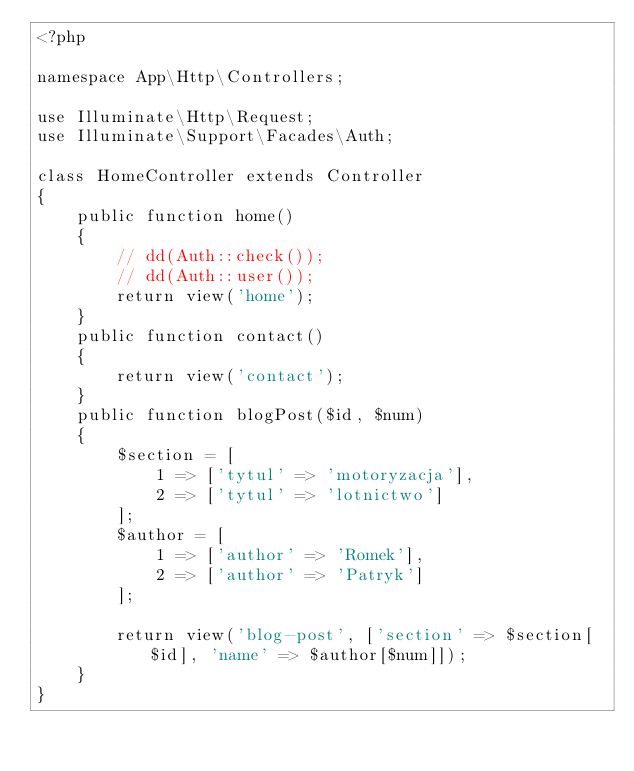<code> <loc_0><loc_0><loc_500><loc_500><_PHP_><?php

namespace App\Http\Controllers;

use Illuminate\Http\Request;
use Illuminate\Support\Facades\Auth;

class HomeController extends Controller
{
    public function home()
    {
        // dd(Auth::check());
        // dd(Auth::user());
        return view('home');
    }
    public function contact()
    {
        return view('contact');
    }
    public function blogPost($id, $num)
    {
        $section = [
            1 => ['tytul' => 'motoryzacja'],
            2 => ['tytul' => 'lotnictwo']
        ];
        $author = [
            1 => ['author' => 'Romek'],
            2 => ['author' => 'Patryk']
        ];

        return view('blog-post', ['section' => $section[$id], 'name' => $author[$num]]);
    }
}
</code> 